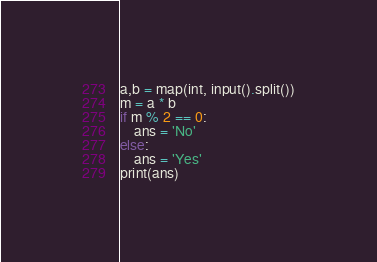<code> <loc_0><loc_0><loc_500><loc_500><_Python_>a,b = map(int, input().split())
m = a * b
if m % 2 == 0:
    ans = 'No'
else:
    ans = 'Yes'
print(ans)
</code> 